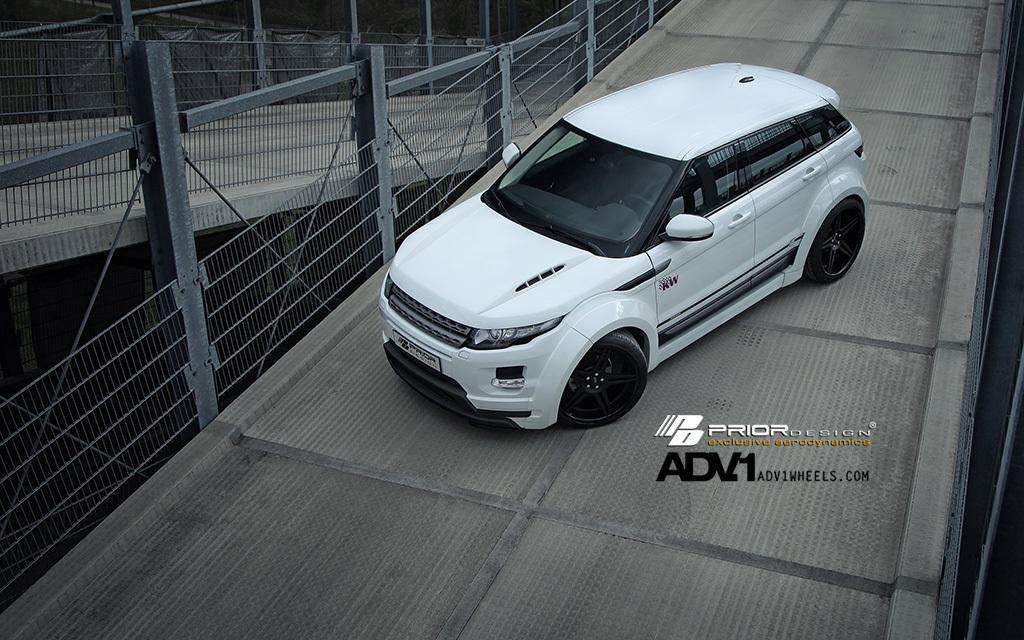Describe this image in one or two sentences. In this picture we can see a white color car, there are two bridges in the front, we can see fencing on the left side, there is some text on the right side. 